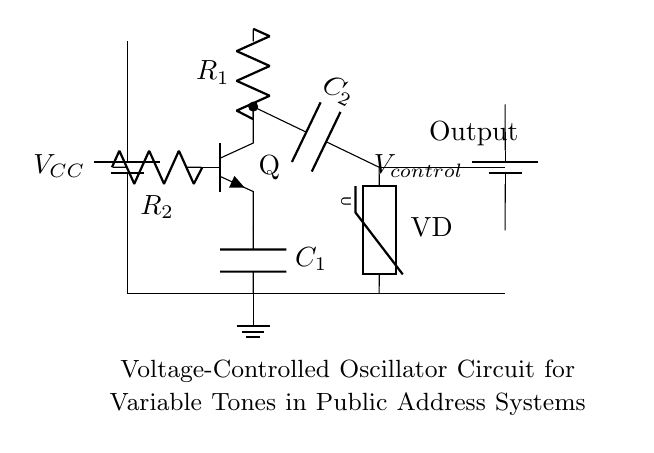what is the power supply voltage in this circuit? The circuit uses a battery labeled as VCC. The value of VCC is not specified in the diagram, but it represents the power supply voltage for the circuit.
Answer: VCC what is the role of the varactor diode? The varactor diode in the circuit is connected in parallel with the capacitor C2, allowing the capacitance to be varied based on the control voltage. This changes the oscillation frequency.
Answer: Frequency modulation how many resistors are present in the circuit? By examining the circuit, there are two resistors labeled as R1 and R2 specifically shown in the diagram, hence the total count is two.
Answer: 2 what does the output represent in this oscillator circuit? The output node in the circuit, labeled as "Output," indicates the point where the generated oscillation signal can be taken for use in the public address system.
Answer: Oscillation signal how does the control voltage affect the oscillator frequency? The control voltage is connected to the varactor diode, which modifies its capacitance. Since frequency depends on capacitance in an oscillator, changing the control voltage alters the oscillation frequency.
Answer: Alters frequency what types of components are used in this oscillator? The circuit comprises a battery, resistors, capacitors, a transistor, and a varactor diode, all of which are standard components used in oscillator circuits.
Answer: Battery, resistors, capacitors, transistor, varactor diode 